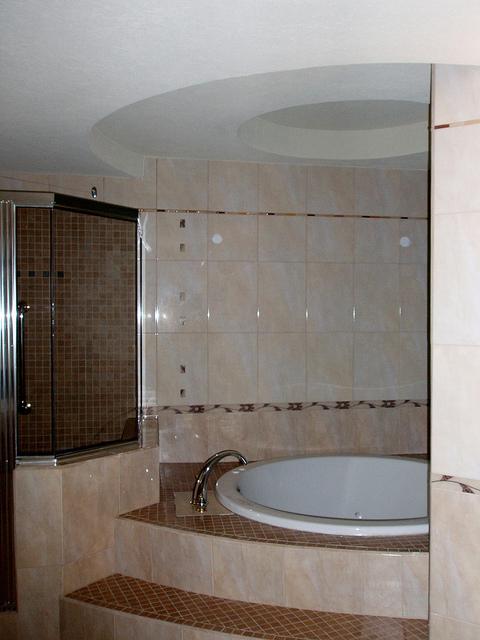Is this a sink or tub?
Write a very short answer. Tub. Where is the shower located?
Write a very short answer. Left. Is the tile in the shower the same size as the tile on the wall outside the shower?
Give a very brief answer. No. 